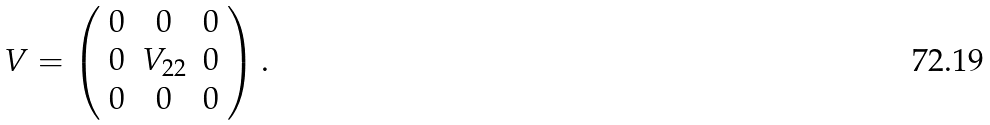Convert formula to latex. <formula><loc_0><loc_0><loc_500><loc_500>V = \left ( \begin{array} { c c c } 0 & 0 & 0 \\ 0 & { V } _ { 2 2 } & 0 \\ 0 & 0 & 0 \end{array} \right ) .</formula> 